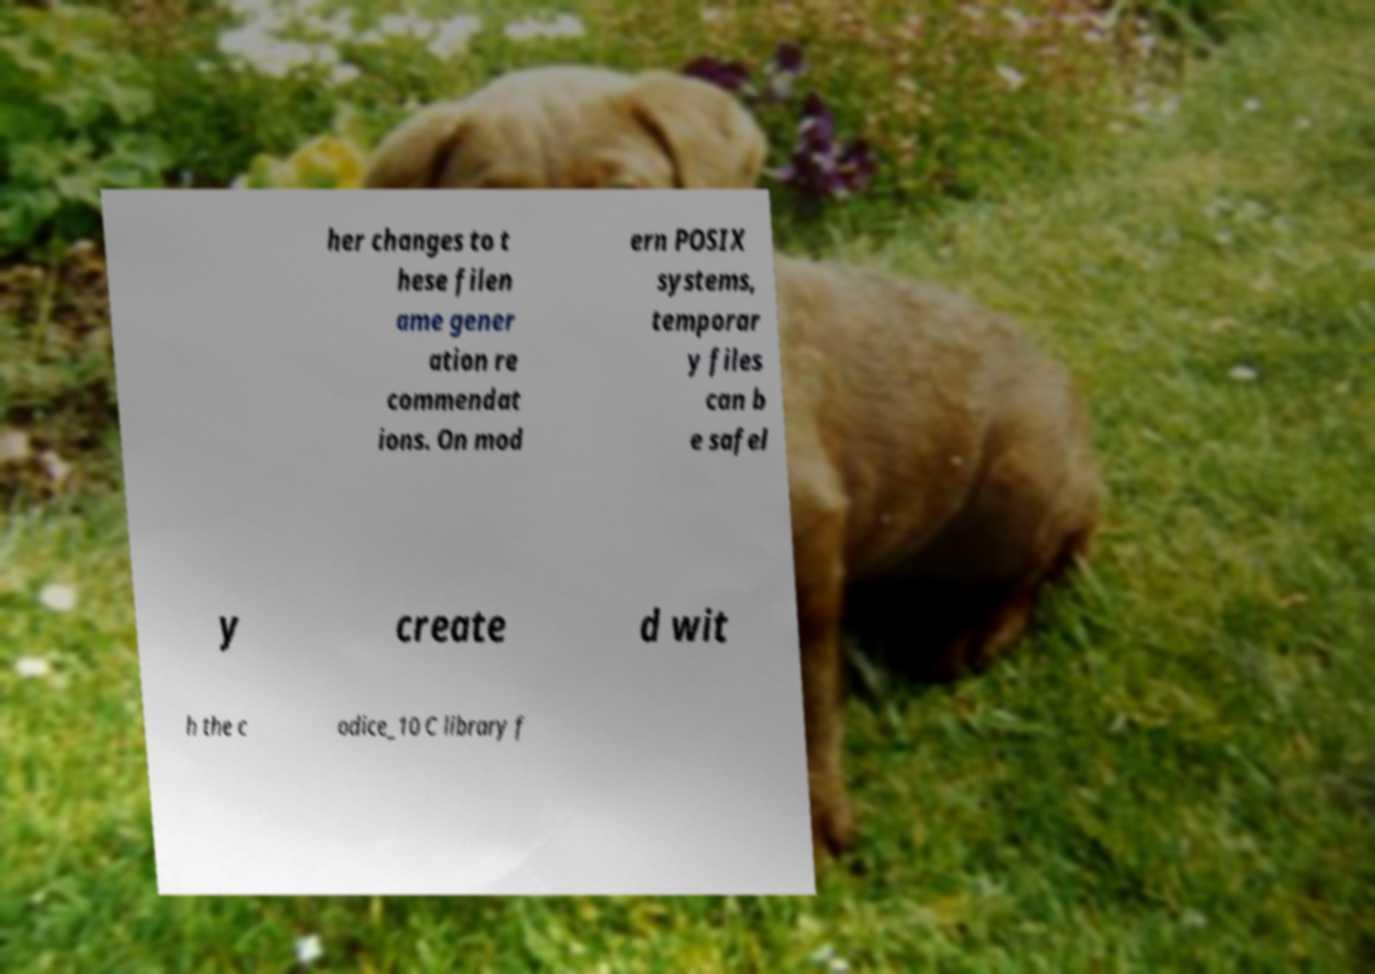What messages or text are displayed in this image? I need them in a readable, typed format. her changes to t hese filen ame gener ation re commendat ions. On mod ern POSIX systems, temporar y files can b e safel y create d wit h the c odice_10 C library f 